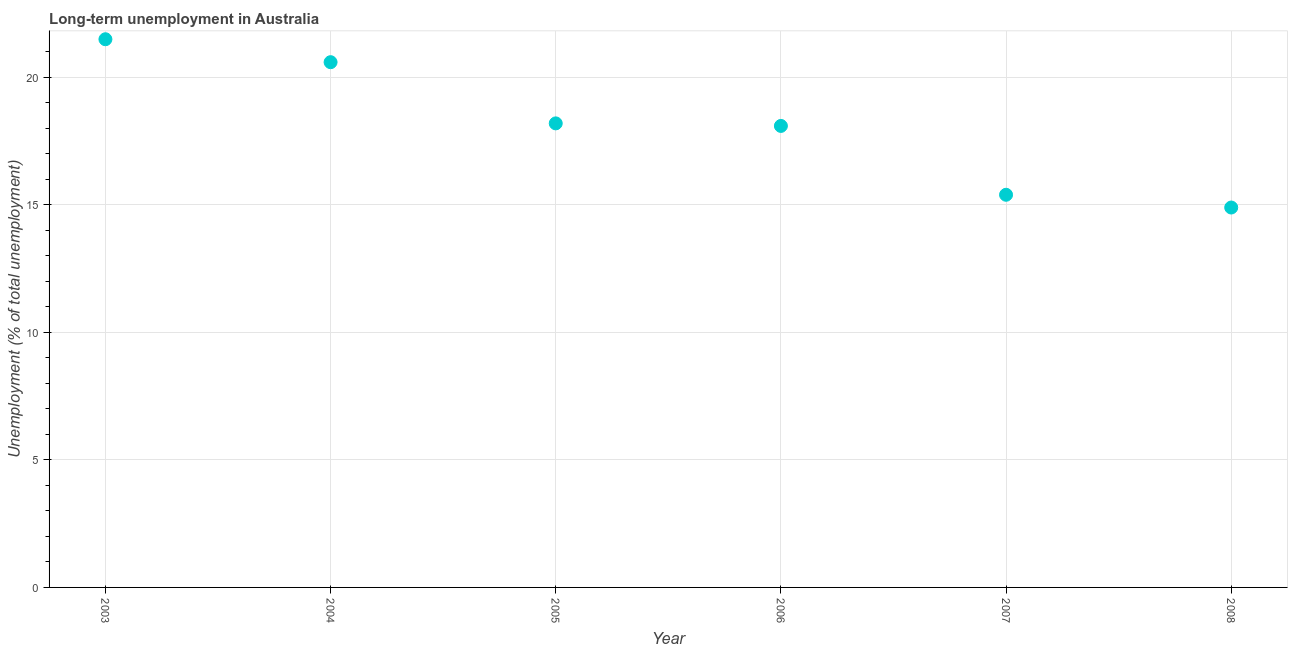What is the long-term unemployment in 2004?
Give a very brief answer. 20.6. Across all years, what is the maximum long-term unemployment?
Your answer should be compact. 21.5. Across all years, what is the minimum long-term unemployment?
Ensure brevity in your answer.  14.9. In which year was the long-term unemployment maximum?
Offer a very short reply. 2003. What is the sum of the long-term unemployment?
Your answer should be compact. 108.7. What is the difference between the long-term unemployment in 2003 and 2007?
Offer a very short reply. 6.1. What is the average long-term unemployment per year?
Provide a short and direct response. 18.12. What is the median long-term unemployment?
Your response must be concise. 18.15. In how many years, is the long-term unemployment greater than 12 %?
Give a very brief answer. 6. What is the ratio of the long-term unemployment in 2006 to that in 2008?
Keep it short and to the point. 1.21. Is the difference between the long-term unemployment in 2004 and 2005 greater than the difference between any two years?
Your answer should be very brief. No. What is the difference between the highest and the second highest long-term unemployment?
Keep it short and to the point. 0.9. What is the difference between the highest and the lowest long-term unemployment?
Your response must be concise. 6.6. What is the difference between two consecutive major ticks on the Y-axis?
Provide a short and direct response. 5. What is the title of the graph?
Offer a very short reply. Long-term unemployment in Australia. What is the label or title of the Y-axis?
Provide a succinct answer. Unemployment (% of total unemployment). What is the Unemployment (% of total unemployment) in 2003?
Make the answer very short. 21.5. What is the Unemployment (% of total unemployment) in 2004?
Ensure brevity in your answer.  20.6. What is the Unemployment (% of total unemployment) in 2005?
Keep it short and to the point. 18.2. What is the Unemployment (% of total unemployment) in 2006?
Give a very brief answer. 18.1. What is the Unemployment (% of total unemployment) in 2007?
Offer a very short reply. 15.4. What is the Unemployment (% of total unemployment) in 2008?
Provide a succinct answer. 14.9. What is the difference between the Unemployment (% of total unemployment) in 2003 and 2006?
Give a very brief answer. 3.4. What is the difference between the Unemployment (% of total unemployment) in 2004 and 2008?
Give a very brief answer. 5.7. What is the difference between the Unemployment (% of total unemployment) in 2005 and 2006?
Keep it short and to the point. 0.1. What is the difference between the Unemployment (% of total unemployment) in 2006 and 2007?
Your response must be concise. 2.7. What is the difference between the Unemployment (% of total unemployment) in 2007 and 2008?
Give a very brief answer. 0.5. What is the ratio of the Unemployment (% of total unemployment) in 2003 to that in 2004?
Your answer should be very brief. 1.04. What is the ratio of the Unemployment (% of total unemployment) in 2003 to that in 2005?
Your answer should be compact. 1.18. What is the ratio of the Unemployment (% of total unemployment) in 2003 to that in 2006?
Make the answer very short. 1.19. What is the ratio of the Unemployment (% of total unemployment) in 2003 to that in 2007?
Your response must be concise. 1.4. What is the ratio of the Unemployment (% of total unemployment) in 2003 to that in 2008?
Offer a terse response. 1.44. What is the ratio of the Unemployment (% of total unemployment) in 2004 to that in 2005?
Provide a short and direct response. 1.13. What is the ratio of the Unemployment (% of total unemployment) in 2004 to that in 2006?
Keep it short and to the point. 1.14. What is the ratio of the Unemployment (% of total unemployment) in 2004 to that in 2007?
Offer a very short reply. 1.34. What is the ratio of the Unemployment (% of total unemployment) in 2004 to that in 2008?
Your response must be concise. 1.38. What is the ratio of the Unemployment (% of total unemployment) in 2005 to that in 2007?
Give a very brief answer. 1.18. What is the ratio of the Unemployment (% of total unemployment) in 2005 to that in 2008?
Provide a succinct answer. 1.22. What is the ratio of the Unemployment (% of total unemployment) in 2006 to that in 2007?
Offer a terse response. 1.18. What is the ratio of the Unemployment (% of total unemployment) in 2006 to that in 2008?
Make the answer very short. 1.22. What is the ratio of the Unemployment (% of total unemployment) in 2007 to that in 2008?
Make the answer very short. 1.03. 